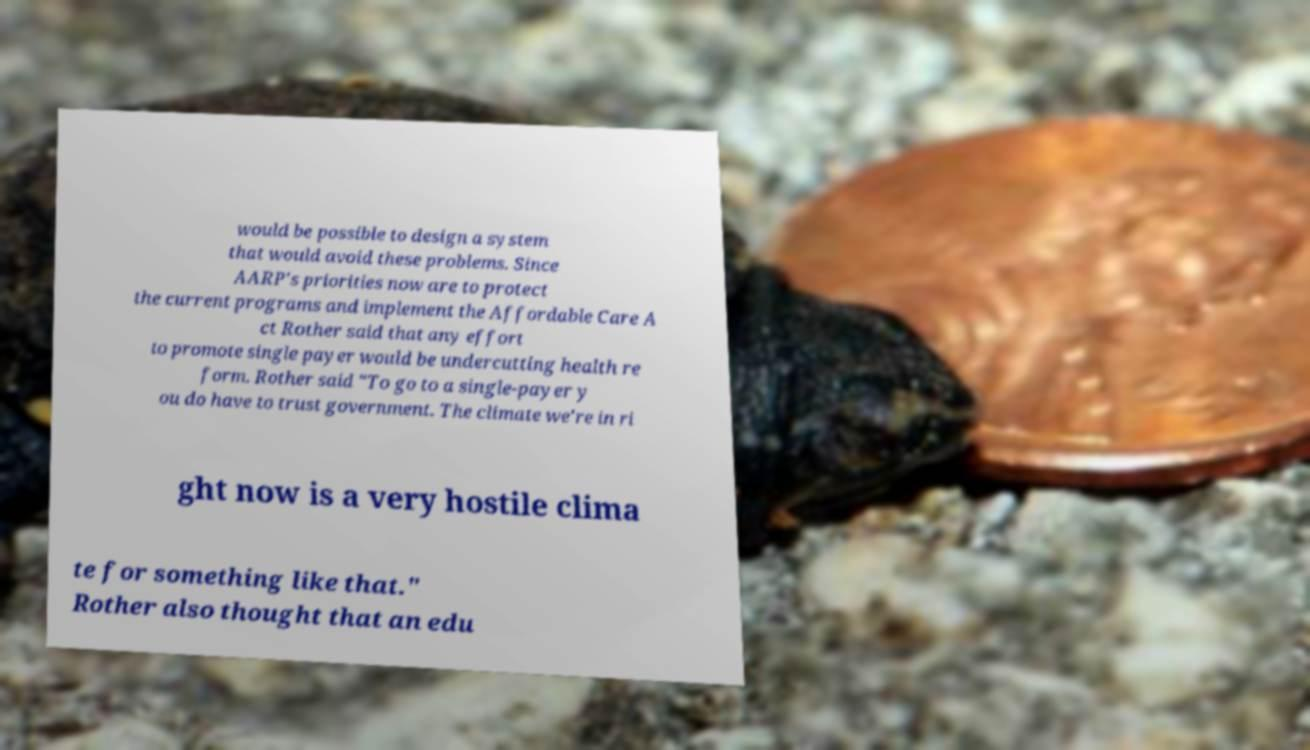Please read and relay the text visible in this image. What does it say? would be possible to design a system that would avoid these problems. Since AARP's priorities now are to protect the current programs and implement the Affordable Care A ct Rother said that any effort to promote single payer would be undercutting health re form. Rother said "To go to a single-payer y ou do have to trust government. The climate we're in ri ght now is a very hostile clima te for something like that." Rother also thought that an edu 